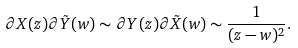Convert formula to latex. <formula><loc_0><loc_0><loc_500><loc_500>\partial X ( z ) \partial \tilde { Y } ( w ) \sim \partial Y ( z ) \partial \tilde { X } ( w ) \sim \frac { 1 } { ( z - w ) ^ { 2 } } .</formula> 